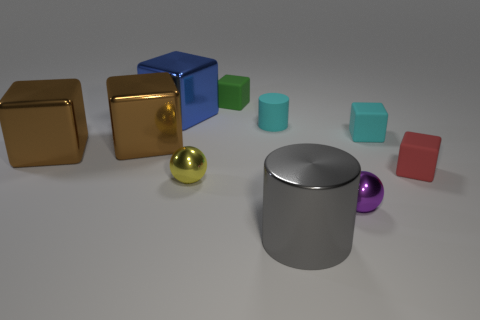What number of things are either large brown objects or rubber objects left of the gray cylinder?
Offer a terse response. 4. The metal sphere right of the sphere that is behind the ball in front of the tiny yellow metal ball is what color?
Ensure brevity in your answer.  Purple. There is a block behind the blue cube; what is its size?
Keep it short and to the point. Small. How many big things are brown things or blue shiny things?
Offer a very short reply. 3. The block that is both to the left of the cyan block and to the right of the small yellow metallic ball is what color?
Your answer should be compact. Green. Are there any small red things of the same shape as the green object?
Provide a succinct answer. Yes. What material is the large gray object?
Offer a terse response. Metal. Are there any small rubber things to the left of the small purple ball?
Ensure brevity in your answer.  Yes. Does the blue metal object have the same shape as the purple thing?
Offer a terse response. No. How many other objects are there of the same size as the gray metal thing?
Ensure brevity in your answer.  3. 